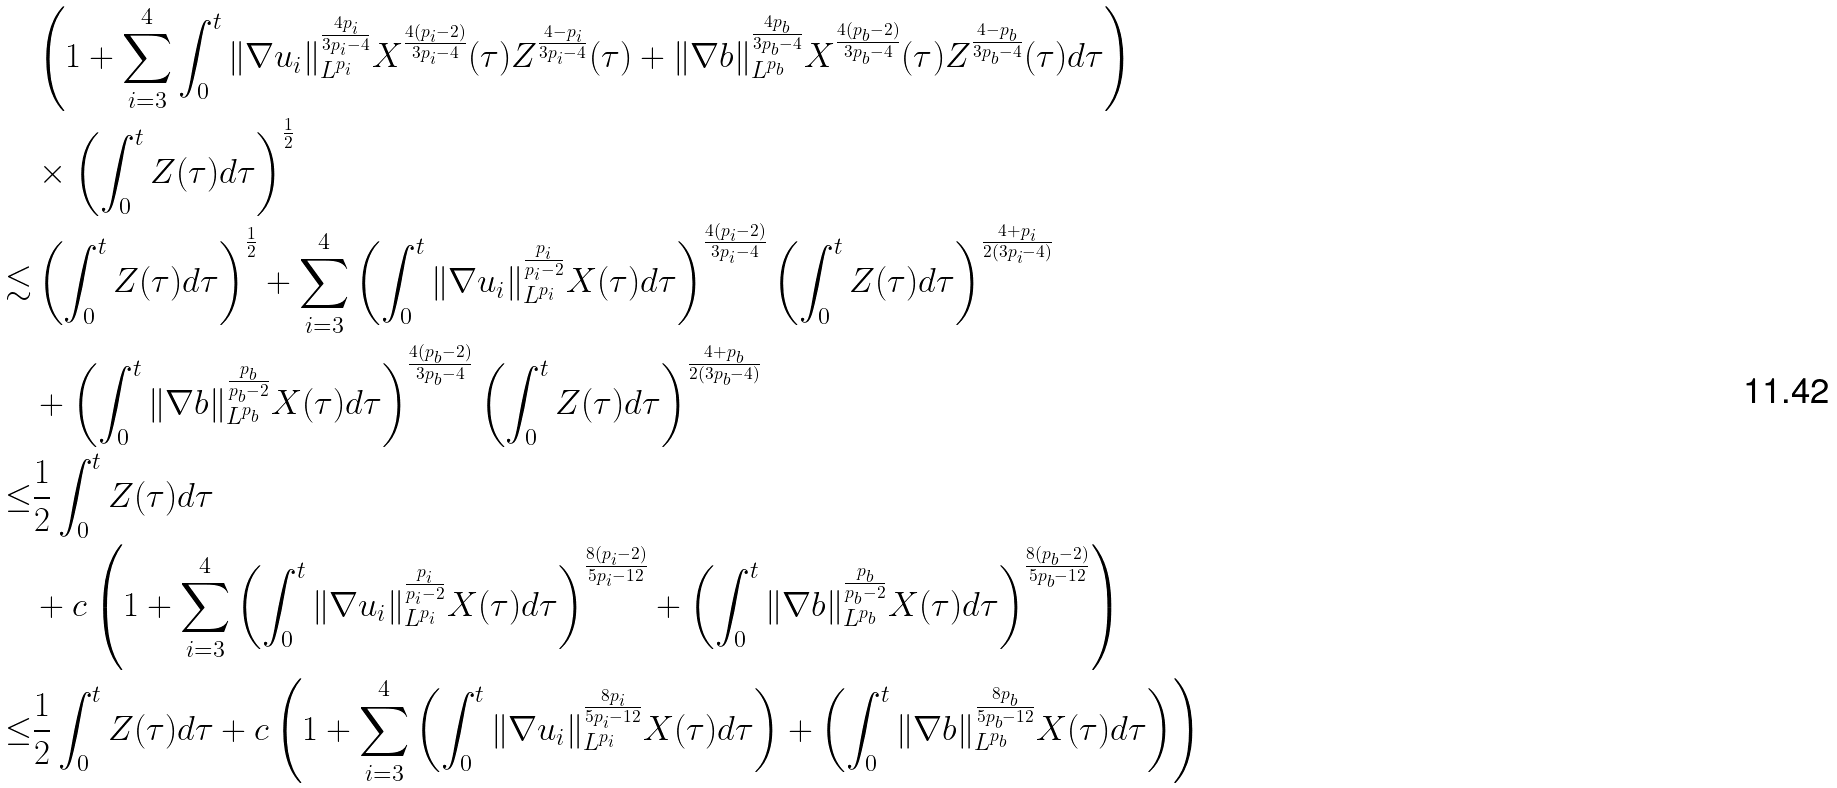Convert formula to latex. <formula><loc_0><loc_0><loc_500><loc_500>& \left ( 1 + \sum _ { i = 3 } ^ { 4 } \int _ { 0 } ^ { t } \| \nabla u _ { i } \| _ { L ^ { p _ { i } } } ^ { \frac { 4 p _ { i } } { 3 p _ { i } - 4 } } X ^ { \frac { 4 ( p _ { i } - 2 ) } { 3 p _ { i } - 4 } } ( \tau ) Z ^ { \frac { 4 - p _ { i } } { 3 p _ { i } - 4 } } ( \tau ) + \| \nabla b \| _ { L ^ { p _ { b } } } ^ { \frac { 4 p _ { b } } { 3 p _ { b } - 4 } } X ^ { \frac { 4 ( p _ { b } - 2 ) } { 3 p _ { b } - 4 } } ( \tau ) Z ^ { \frac { 4 - p _ { b } } { 3 p _ { b } - 4 } } ( \tau ) d \tau \right ) \\ & \times \left ( \int _ { 0 } ^ { t } Z ( \tau ) d \tau \right ) ^ { \frac { 1 } { 2 } } \\ \lesssim & \left ( \int _ { 0 } ^ { t } Z ( \tau ) d \tau \right ) ^ { \frac { 1 } { 2 } } + \sum _ { i = 3 } ^ { 4 } \left ( \int _ { 0 } ^ { t } \| \nabla u _ { i } \| _ { L ^ { p _ { i } } } ^ { \frac { p _ { i } } { p _ { i } - 2 } } X ( \tau ) d \tau \right ) ^ { \frac { 4 ( p _ { i } - 2 ) } { 3 p _ { i } - 4 } } \left ( \int _ { 0 } ^ { t } Z ( \tau ) d \tau \right ) ^ { \frac { 4 + p _ { i } } { 2 ( 3 p _ { i } - 4 ) } } \\ & + \left ( \int _ { 0 } ^ { t } \| \nabla b \| _ { L ^ { p _ { b } } } ^ { \frac { p _ { b } } { p _ { b } - 2 } } X ( \tau ) d \tau \right ) ^ { \frac { 4 ( p _ { b } - 2 ) } { 3 p _ { b } - 4 } } \left ( \int _ { 0 } ^ { t } Z ( \tau ) d \tau \right ) ^ { \frac { 4 + p _ { b } } { 2 ( 3 p _ { b } - 4 ) } } \\ \leq & \frac { 1 } { 2 } \int _ { 0 } ^ { t } Z ( \tau ) d \tau \\ & + c \left ( 1 + \sum _ { i = 3 } ^ { 4 } \left ( \int _ { 0 } ^ { t } \| \nabla u _ { i } \| _ { L ^ { p _ { i } } } ^ { \frac { p _ { i } } { p _ { i } - 2 } } X ( \tau ) d \tau \right ) ^ { \frac { 8 ( p _ { i } - 2 ) } { 5 p _ { i } - 1 2 } } + \left ( \int _ { 0 } ^ { t } \| \nabla b \| _ { L ^ { p _ { b } } } ^ { \frac { p _ { b } } { p _ { b } - 2 } } X ( \tau ) d \tau \right ) ^ { \frac { 8 ( p _ { b } - 2 ) } { 5 p _ { b } - 1 2 } } \right ) \\ \leq & \frac { 1 } { 2 } \int _ { 0 } ^ { t } Z ( \tau ) d \tau + c \left ( 1 + \sum _ { i = 3 } ^ { 4 } \left ( \int _ { 0 } ^ { t } \| \nabla u _ { i } \| _ { L ^ { p _ { i } } } ^ { \frac { 8 p _ { i } } { 5 p _ { i } - 1 2 } } X ( \tau ) d \tau \right ) + \left ( \int _ { 0 } ^ { t } \| \nabla b \| _ { L ^ { p _ { b } } } ^ { \frac { 8 p _ { b } } { 5 p _ { b } - 1 2 } } X ( \tau ) d \tau \right ) \right )</formula> 